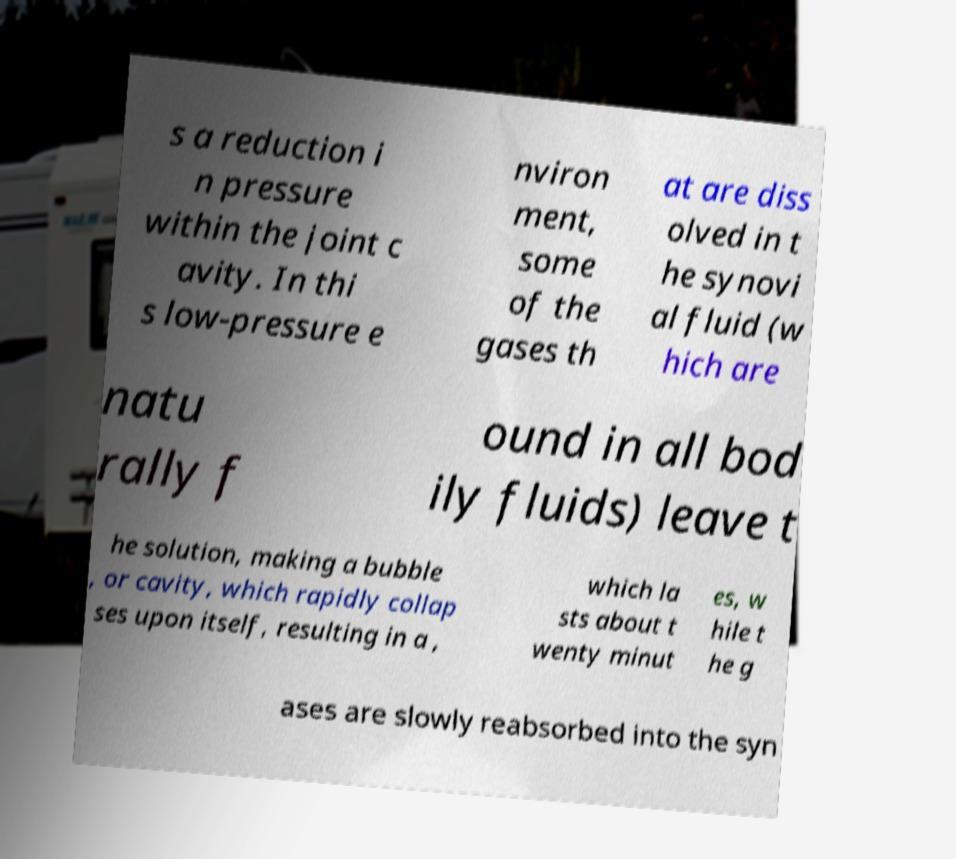What messages or text are displayed in this image? I need them in a readable, typed format. s a reduction i n pressure within the joint c avity. In thi s low-pressure e nviron ment, some of the gases th at are diss olved in t he synovi al fluid (w hich are natu rally f ound in all bod ily fluids) leave t he solution, making a bubble , or cavity, which rapidly collap ses upon itself, resulting in a , which la sts about t wenty minut es, w hile t he g ases are slowly reabsorbed into the syn 